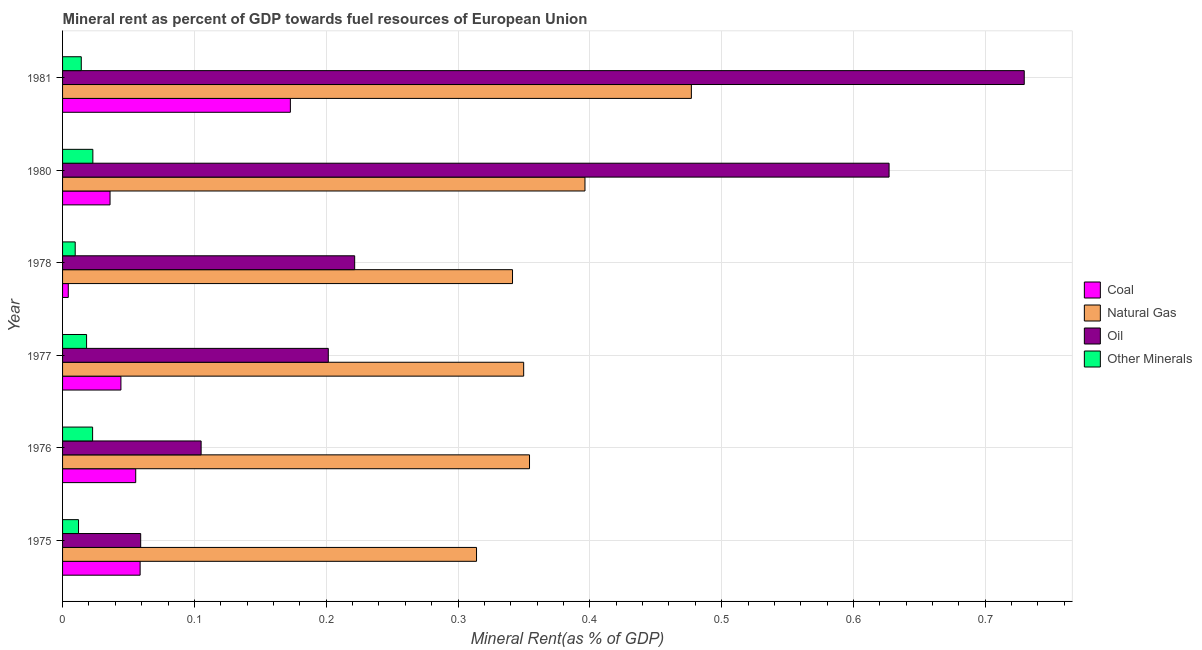How many different coloured bars are there?
Offer a terse response. 4. How many groups of bars are there?
Provide a short and direct response. 6. Are the number of bars per tick equal to the number of legend labels?
Your answer should be very brief. Yes. Are the number of bars on each tick of the Y-axis equal?
Provide a succinct answer. Yes. How many bars are there on the 1st tick from the top?
Ensure brevity in your answer.  4. What is the  rent of other minerals in 1978?
Give a very brief answer. 0.01. Across all years, what is the maximum coal rent?
Provide a short and direct response. 0.17. Across all years, what is the minimum natural gas rent?
Ensure brevity in your answer.  0.31. In which year was the coal rent minimum?
Your answer should be very brief. 1978. What is the total natural gas rent in the graph?
Offer a very short reply. 2.23. What is the difference between the natural gas rent in 1978 and that in 1980?
Ensure brevity in your answer.  -0.06. What is the difference between the  rent of other minerals in 1981 and the oil rent in 1975?
Keep it short and to the point. -0.05. What is the average natural gas rent per year?
Your answer should be compact. 0.37. In the year 1976, what is the difference between the oil rent and natural gas rent?
Your answer should be compact. -0.25. In how many years, is the oil rent greater than 0.4 %?
Your answer should be compact. 2. What is the ratio of the natural gas rent in 1976 to that in 1980?
Make the answer very short. 0.89. Is the  rent of other minerals in 1975 less than that in 1977?
Provide a short and direct response. Yes. What is the difference between the highest and the second highest oil rent?
Give a very brief answer. 0.1. What is the difference between the highest and the lowest natural gas rent?
Offer a terse response. 0.16. Is the sum of the  rent of other minerals in 1975 and 1976 greater than the maximum natural gas rent across all years?
Your response must be concise. No. What does the 2nd bar from the top in 1981 represents?
Keep it short and to the point. Oil. What does the 4th bar from the bottom in 1978 represents?
Make the answer very short. Other Minerals. Is it the case that in every year, the sum of the coal rent and natural gas rent is greater than the oil rent?
Offer a very short reply. No. How many years are there in the graph?
Offer a very short reply. 6. Are the values on the major ticks of X-axis written in scientific E-notation?
Make the answer very short. No. Does the graph contain grids?
Keep it short and to the point. Yes. What is the title of the graph?
Provide a short and direct response. Mineral rent as percent of GDP towards fuel resources of European Union. What is the label or title of the X-axis?
Your response must be concise. Mineral Rent(as % of GDP). What is the Mineral Rent(as % of GDP) in Coal in 1975?
Your response must be concise. 0.06. What is the Mineral Rent(as % of GDP) of Natural Gas in 1975?
Provide a succinct answer. 0.31. What is the Mineral Rent(as % of GDP) in Oil in 1975?
Your answer should be compact. 0.06. What is the Mineral Rent(as % of GDP) of Other Minerals in 1975?
Ensure brevity in your answer.  0.01. What is the Mineral Rent(as % of GDP) in Coal in 1976?
Your response must be concise. 0.06. What is the Mineral Rent(as % of GDP) in Natural Gas in 1976?
Your answer should be compact. 0.35. What is the Mineral Rent(as % of GDP) in Oil in 1976?
Provide a short and direct response. 0.11. What is the Mineral Rent(as % of GDP) in Other Minerals in 1976?
Keep it short and to the point. 0.02. What is the Mineral Rent(as % of GDP) of Coal in 1977?
Keep it short and to the point. 0.04. What is the Mineral Rent(as % of GDP) of Natural Gas in 1977?
Give a very brief answer. 0.35. What is the Mineral Rent(as % of GDP) in Oil in 1977?
Provide a succinct answer. 0.2. What is the Mineral Rent(as % of GDP) in Other Minerals in 1977?
Your response must be concise. 0.02. What is the Mineral Rent(as % of GDP) in Coal in 1978?
Make the answer very short. 0. What is the Mineral Rent(as % of GDP) of Natural Gas in 1978?
Give a very brief answer. 0.34. What is the Mineral Rent(as % of GDP) of Oil in 1978?
Offer a terse response. 0.22. What is the Mineral Rent(as % of GDP) of Other Minerals in 1978?
Give a very brief answer. 0.01. What is the Mineral Rent(as % of GDP) of Coal in 1980?
Your answer should be very brief. 0.04. What is the Mineral Rent(as % of GDP) of Natural Gas in 1980?
Make the answer very short. 0.4. What is the Mineral Rent(as % of GDP) in Oil in 1980?
Ensure brevity in your answer.  0.63. What is the Mineral Rent(as % of GDP) in Other Minerals in 1980?
Offer a terse response. 0.02. What is the Mineral Rent(as % of GDP) in Coal in 1981?
Ensure brevity in your answer.  0.17. What is the Mineral Rent(as % of GDP) of Natural Gas in 1981?
Your response must be concise. 0.48. What is the Mineral Rent(as % of GDP) in Oil in 1981?
Keep it short and to the point. 0.73. What is the Mineral Rent(as % of GDP) in Other Minerals in 1981?
Your answer should be very brief. 0.01. Across all years, what is the maximum Mineral Rent(as % of GDP) of Coal?
Your response must be concise. 0.17. Across all years, what is the maximum Mineral Rent(as % of GDP) of Natural Gas?
Provide a succinct answer. 0.48. Across all years, what is the maximum Mineral Rent(as % of GDP) of Oil?
Provide a short and direct response. 0.73. Across all years, what is the maximum Mineral Rent(as % of GDP) in Other Minerals?
Provide a succinct answer. 0.02. Across all years, what is the minimum Mineral Rent(as % of GDP) in Coal?
Give a very brief answer. 0. Across all years, what is the minimum Mineral Rent(as % of GDP) of Natural Gas?
Your response must be concise. 0.31. Across all years, what is the minimum Mineral Rent(as % of GDP) of Oil?
Your answer should be very brief. 0.06. Across all years, what is the minimum Mineral Rent(as % of GDP) in Other Minerals?
Make the answer very short. 0.01. What is the total Mineral Rent(as % of GDP) in Coal in the graph?
Your response must be concise. 0.37. What is the total Mineral Rent(as % of GDP) in Natural Gas in the graph?
Provide a succinct answer. 2.23. What is the total Mineral Rent(as % of GDP) in Oil in the graph?
Your answer should be compact. 1.94. What is the total Mineral Rent(as % of GDP) in Other Minerals in the graph?
Ensure brevity in your answer.  0.1. What is the difference between the Mineral Rent(as % of GDP) in Coal in 1975 and that in 1976?
Provide a succinct answer. 0. What is the difference between the Mineral Rent(as % of GDP) in Natural Gas in 1975 and that in 1976?
Provide a short and direct response. -0.04. What is the difference between the Mineral Rent(as % of GDP) of Oil in 1975 and that in 1976?
Ensure brevity in your answer.  -0.05. What is the difference between the Mineral Rent(as % of GDP) of Other Minerals in 1975 and that in 1976?
Give a very brief answer. -0.01. What is the difference between the Mineral Rent(as % of GDP) in Coal in 1975 and that in 1977?
Provide a short and direct response. 0.01. What is the difference between the Mineral Rent(as % of GDP) in Natural Gas in 1975 and that in 1977?
Offer a terse response. -0.04. What is the difference between the Mineral Rent(as % of GDP) of Oil in 1975 and that in 1977?
Offer a very short reply. -0.14. What is the difference between the Mineral Rent(as % of GDP) of Other Minerals in 1975 and that in 1977?
Give a very brief answer. -0.01. What is the difference between the Mineral Rent(as % of GDP) in Coal in 1975 and that in 1978?
Your answer should be very brief. 0.05. What is the difference between the Mineral Rent(as % of GDP) in Natural Gas in 1975 and that in 1978?
Give a very brief answer. -0.03. What is the difference between the Mineral Rent(as % of GDP) of Oil in 1975 and that in 1978?
Provide a succinct answer. -0.16. What is the difference between the Mineral Rent(as % of GDP) in Other Minerals in 1975 and that in 1978?
Provide a succinct answer. 0. What is the difference between the Mineral Rent(as % of GDP) of Coal in 1975 and that in 1980?
Provide a succinct answer. 0.02. What is the difference between the Mineral Rent(as % of GDP) in Natural Gas in 1975 and that in 1980?
Your response must be concise. -0.08. What is the difference between the Mineral Rent(as % of GDP) of Oil in 1975 and that in 1980?
Provide a short and direct response. -0.57. What is the difference between the Mineral Rent(as % of GDP) in Other Minerals in 1975 and that in 1980?
Provide a short and direct response. -0.01. What is the difference between the Mineral Rent(as % of GDP) in Coal in 1975 and that in 1981?
Provide a short and direct response. -0.11. What is the difference between the Mineral Rent(as % of GDP) in Natural Gas in 1975 and that in 1981?
Provide a short and direct response. -0.16. What is the difference between the Mineral Rent(as % of GDP) in Oil in 1975 and that in 1981?
Offer a terse response. -0.67. What is the difference between the Mineral Rent(as % of GDP) of Other Minerals in 1975 and that in 1981?
Your answer should be very brief. -0. What is the difference between the Mineral Rent(as % of GDP) of Coal in 1976 and that in 1977?
Keep it short and to the point. 0.01. What is the difference between the Mineral Rent(as % of GDP) in Natural Gas in 1976 and that in 1977?
Your response must be concise. 0. What is the difference between the Mineral Rent(as % of GDP) of Oil in 1976 and that in 1977?
Ensure brevity in your answer.  -0.1. What is the difference between the Mineral Rent(as % of GDP) in Other Minerals in 1976 and that in 1977?
Make the answer very short. 0. What is the difference between the Mineral Rent(as % of GDP) in Coal in 1976 and that in 1978?
Offer a terse response. 0.05. What is the difference between the Mineral Rent(as % of GDP) in Natural Gas in 1976 and that in 1978?
Keep it short and to the point. 0.01. What is the difference between the Mineral Rent(as % of GDP) of Oil in 1976 and that in 1978?
Your response must be concise. -0.12. What is the difference between the Mineral Rent(as % of GDP) of Other Minerals in 1976 and that in 1978?
Make the answer very short. 0.01. What is the difference between the Mineral Rent(as % of GDP) of Coal in 1976 and that in 1980?
Give a very brief answer. 0.02. What is the difference between the Mineral Rent(as % of GDP) in Natural Gas in 1976 and that in 1980?
Your response must be concise. -0.04. What is the difference between the Mineral Rent(as % of GDP) of Oil in 1976 and that in 1980?
Offer a terse response. -0.52. What is the difference between the Mineral Rent(as % of GDP) in Other Minerals in 1976 and that in 1980?
Your response must be concise. -0. What is the difference between the Mineral Rent(as % of GDP) in Coal in 1976 and that in 1981?
Your answer should be compact. -0.12. What is the difference between the Mineral Rent(as % of GDP) of Natural Gas in 1976 and that in 1981?
Keep it short and to the point. -0.12. What is the difference between the Mineral Rent(as % of GDP) in Oil in 1976 and that in 1981?
Your answer should be compact. -0.62. What is the difference between the Mineral Rent(as % of GDP) of Other Minerals in 1976 and that in 1981?
Provide a succinct answer. 0.01. What is the difference between the Mineral Rent(as % of GDP) in Coal in 1977 and that in 1978?
Provide a short and direct response. 0.04. What is the difference between the Mineral Rent(as % of GDP) in Natural Gas in 1977 and that in 1978?
Offer a terse response. 0.01. What is the difference between the Mineral Rent(as % of GDP) of Oil in 1977 and that in 1978?
Your answer should be very brief. -0.02. What is the difference between the Mineral Rent(as % of GDP) of Other Minerals in 1977 and that in 1978?
Give a very brief answer. 0.01. What is the difference between the Mineral Rent(as % of GDP) in Coal in 1977 and that in 1980?
Ensure brevity in your answer.  0.01. What is the difference between the Mineral Rent(as % of GDP) in Natural Gas in 1977 and that in 1980?
Give a very brief answer. -0.05. What is the difference between the Mineral Rent(as % of GDP) in Oil in 1977 and that in 1980?
Your answer should be very brief. -0.43. What is the difference between the Mineral Rent(as % of GDP) in Other Minerals in 1977 and that in 1980?
Give a very brief answer. -0. What is the difference between the Mineral Rent(as % of GDP) of Coal in 1977 and that in 1981?
Your answer should be compact. -0.13. What is the difference between the Mineral Rent(as % of GDP) in Natural Gas in 1977 and that in 1981?
Your answer should be compact. -0.13. What is the difference between the Mineral Rent(as % of GDP) in Oil in 1977 and that in 1981?
Offer a terse response. -0.53. What is the difference between the Mineral Rent(as % of GDP) of Other Minerals in 1977 and that in 1981?
Offer a terse response. 0. What is the difference between the Mineral Rent(as % of GDP) in Coal in 1978 and that in 1980?
Give a very brief answer. -0.03. What is the difference between the Mineral Rent(as % of GDP) of Natural Gas in 1978 and that in 1980?
Provide a short and direct response. -0.06. What is the difference between the Mineral Rent(as % of GDP) of Oil in 1978 and that in 1980?
Offer a terse response. -0.41. What is the difference between the Mineral Rent(as % of GDP) in Other Minerals in 1978 and that in 1980?
Offer a terse response. -0.01. What is the difference between the Mineral Rent(as % of GDP) in Coal in 1978 and that in 1981?
Give a very brief answer. -0.17. What is the difference between the Mineral Rent(as % of GDP) in Natural Gas in 1978 and that in 1981?
Your answer should be very brief. -0.14. What is the difference between the Mineral Rent(as % of GDP) of Oil in 1978 and that in 1981?
Offer a terse response. -0.51. What is the difference between the Mineral Rent(as % of GDP) in Other Minerals in 1978 and that in 1981?
Your answer should be very brief. -0. What is the difference between the Mineral Rent(as % of GDP) in Coal in 1980 and that in 1981?
Make the answer very short. -0.14. What is the difference between the Mineral Rent(as % of GDP) in Natural Gas in 1980 and that in 1981?
Offer a terse response. -0.08. What is the difference between the Mineral Rent(as % of GDP) in Oil in 1980 and that in 1981?
Provide a succinct answer. -0.1. What is the difference between the Mineral Rent(as % of GDP) of Other Minerals in 1980 and that in 1981?
Keep it short and to the point. 0.01. What is the difference between the Mineral Rent(as % of GDP) in Coal in 1975 and the Mineral Rent(as % of GDP) in Natural Gas in 1976?
Ensure brevity in your answer.  -0.3. What is the difference between the Mineral Rent(as % of GDP) in Coal in 1975 and the Mineral Rent(as % of GDP) in Oil in 1976?
Your answer should be very brief. -0.05. What is the difference between the Mineral Rent(as % of GDP) in Coal in 1975 and the Mineral Rent(as % of GDP) in Other Minerals in 1976?
Your answer should be compact. 0.04. What is the difference between the Mineral Rent(as % of GDP) in Natural Gas in 1975 and the Mineral Rent(as % of GDP) in Oil in 1976?
Keep it short and to the point. 0.21. What is the difference between the Mineral Rent(as % of GDP) in Natural Gas in 1975 and the Mineral Rent(as % of GDP) in Other Minerals in 1976?
Your response must be concise. 0.29. What is the difference between the Mineral Rent(as % of GDP) of Oil in 1975 and the Mineral Rent(as % of GDP) of Other Minerals in 1976?
Make the answer very short. 0.04. What is the difference between the Mineral Rent(as % of GDP) in Coal in 1975 and the Mineral Rent(as % of GDP) in Natural Gas in 1977?
Your answer should be very brief. -0.29. What is the difference between the Mineral Rent(as % of GDP) of Coal in 1975 and the Mineral Rent(as % of GDP) of Oil in 1977?
Offer a terse response. -0.14. What is the difference between the Mineral Rent(as % of GDP) of Coal in 1975 and the Mineral Rent(as % of GDP) of Other Minerals in 1977?
Make the answer very short. 0.04. What is the difference between the Mineral Rent(as % of GDP) in Natural Gas in 1975 and the Mineral Rent(as % of GDP) in Oil in 1977?
Your answer should be compact. 0.11. What is the difference between the Mineral Rent(as % of GDP) in Natural Gas in 1975 and the Mineral Rent(as % of GDP) in Other Minerals in 1977?
Ensure brevity in your answer.  0.3. What is the difference between the Mineral Rent(as % of GDP) in Oil in 1975 and the Mineral Rent(as % of GDP) in Other Minerals in 1977?
Make the answer very short. 0.04. What is the difference between the Mineral Rent(as % of GDP) of Coal in 1975 and the Mineral Rent(as % of GDP) of Natural Gas in 1978?
Your answer should be very brief. -0.28. What is the difference between the Mineral Rent(as % of GDP) in Coal in 1975 and the Mineral Rent(as % of GDP) in Oil in 1978?
Offer a very short reply. -0.16. What is the difference between the Mineral Rent(as % of GDP) of Coal in 1975 and the Mineral Rent(as % of GDP) of Other Minerals in 1978?
Offer a very short reply. 0.05. What is the difference between the Mineral Rent(as % of GDP) in Natural Gas in 1975 and the Mineral Rent(as % of GDP) in Oil in 1978?
Provide a succinct answer. 0.09. What is the difference between the Mineral Rent(as % of GDP) of Natural Gas in 1975 and the Mineral Rent(as % of GDP) of Other Minerals in 1978?
Make the answer very short. 0.3. What is the difference between the Mineral Rent(as % of GDP) of Oil in 1975 and the Mineral Rent(as % of GDP) of Other Minerals in 1978?
Your response must be concise. 0.05. What is the difference between the Mineral Rent(as % of GDP) in Coal in 1975 and the Mineral Rent(as % of GDP) in Natural Gas in 1980?
Provide a succinct answer. -0.34. What is the difference between the Mineral Rent(as % of GDP) of Coal in 1975 and the Mineral Rent(as % of GDP) of Oil in 1980?
Your answer should be compact. -0.57. What is the difference between the Mineral Rent(as % of GDP) of Coal in 1975 and the Mineral Rent(as % of GDP) of Other Minerals in 1980?
Make the answer very short. 0.04. What is the difference between the Mineral Rent(as % of GDP) of Natural Gas in 1975 and the Mineral Rent(as % of GDP) of Oil in 1980?
Provide a short and direct response. -0.31. What is the difference between the Mineral Rent(as % of GDP) in Natural Gas in 1975 and the Mineral Rent(as % of GDP) in Other Minerals in 1980?
Provide a short and direct response. 0.29. What is the difference between the Mineral Rent(as % of GDP) of Oil in 1975 and the Mineral Rent(as % of GDP) of Other Minerals in 1980?
Provide a succinct answer. 0.04. What is the difference between the Mineral Rent(as % of GDP) of Coal in 1975 and the Mineral Rent(as % of GDP) of Natural Gas in 1981?
Provide a succinct answer. -0.42. What is the difference between the Mineral Rent(as % of GDP) of Coal in 1975 and the Mineral Rent(as % of GDP) of Oil in 1981?
Give a very brief answer. -0.67. What is the difference between the Mineral Rent(as % of GDP) in Coal in 1975 and the Mineral Rent(as % of GDP) in Other Minerals in 1981?
Your answer should be very brief. 0.04. What is the difference between the Mineral Rent(as % of GDP) in Natural Gas in 1975 and the Mineral Rent(as % of GDP) in Oil in 1981?
Offer a very short reply. -0.42. What is the difference between the Mineral Rent(as % of GDP) in Natural Gas in 1975 and the Mineral Rent(as % of GDP) in Other Minerals in 1981?
Offer a terse response. 0.3. What is the difference between the Mineral Rent(as % of GDP) of Oil in 1975 and the Mineral Rent(as % of GDP) of Other Minerals in 1981?
Your answer should be very brief. 0.05. What is the difference between the Mineral Rent(as % of GDP) in Coal in 1976 and the Mineral Rent(as % of GDP) in Natural Gas in 1977?
Provide a short and direct response. -0.29. What is the difference between the Mineral Rent(as % of GDP) in Coal in 1976 and the Mineral Rent(as % of GDP) in Oil in 1977?
Give a very brief answer. -0.15. What is the difference between the Mineral Rent(as % of GDP) in Coal in 1976 and the Mineral Rent(as % of GDP) in Other Minerals in 1977?
Make the answer very short. 0.04. What is the difference between the Mineral Rent(as % of GDP) of Natural Gas in 1976 and the Mineral Rent(as % of GDP) of Oil in 1977?
Your answer should be very brief. 0.15. What is the difference between the Mineral Rent(as % of GDP) in Natural Gas in 1976 and the Mineral Rent(as % of GDP) in Other Minerals in 1977?
Give a very brief answer. 0.34. What is the difference between the Mineral Rent(as % of GDP) of Oil in 1976 and the Mineral Rent(as % of GDP) of Other Minerals in 1977?
Give a very brief answer. 0.09. What is the difference between the Mineral Rent(as % of GDP) in Coal in 1976 and the Mineral Rent(as % of GDP) in Natural Gas in 1978?
Offer a terse response. -0.29. What is the difference between the Mineral Rent(as % of GDP) in Coal in 1976 and the Mineral Rent(as % of GDP) in Oil in 1978?
Offer a very short reply. -0.17. What is the difference between the Mineral Rent(as % of GDP) in Coal in 1976 and the Mineral Rent(as % of GDP) in Other Minerals in 1978?
Your answer should be very brief. 0.05. What is the difference between the Mineral Rent(as % of GDP) of Natural Gas in 1976 and the Mineral Rent(as % of GDP) of Oil in 1978?
Provide a short and direct response. 0.13. What is the difference between the Mineral Rent(as % of GDP) in Natural Gas in 1976 and the Mineral Rent(as % of GDP) in Other Minerals in 1978?
Offer a terse response. 0.34. What is the difference between the Mineral Rent(as % of GDP) of Oil in 1976 and the Mineral Rent(as % of GDP) of Other Minerals in 1978?
Provide a short and direct response. 0.1. What is the difference between the Mineral Rent(as % of GDP) in Coal in 1976 and the Mineral Rent(as % of GDP) in Natural Gas in 1980?
Your answer should be very brief. -0.34. What is the difference between the Mineral Rent(as % of GDP) of Coal in 1976 and the Mineral Rent(as % of GDP) of Oil in 1980?
Give a very brief answer. -0.57. What is the difference between the Mineral Rent(as % of GDP) of Coal in 1976 and the Mineral Rent(as % of GDP) of Other Minerals in 1980?
Your answer should be very brief. 0.03. What is the difference between the Mineral Rent(as % of GDP) of Natural Gas in 1976 and the Mineral Rent(as % of GDP) of Oil in 1980?
Your answer should be compact. -0.27. What is the difference between the Mineral Rent(as % of GDP) of Natural Gas in 1976 and the Mineral Rent(as % of GDP) of Other Minerals in 1980?
Keep it short and to the point. 0.33. What is the difference between the Mineral Rent(as % of GDP) of Oil in 1976 and the Mineral Rent(as % of GDP) of Other Minerals in 1980?
Keep it short and to the point. 0.08. What is the difference between the Mineral Rent(as % of GDP) in Coal in 1976 and the Mineral Rent(as % of GDP) in Natural Gas in 1981?
Your response must be concise. -0.42. What is the difference between the Mineral Rent(as % of GDP) of Coal in 1976 and the Mineral Rent(as % of GDP) of Oil in 1981?
Your response must be concise. -0.67. What is the difference between the Mineral Rent(as % of GDP) of Coal in 1976 and the Mineral Rent(as % of GDP) of Other Minerals in 1981?
Offer a very short reply. 0.04. What is the difference between the Mineral Rent(as % of GDP) of Natural Gas in 1976 and the Mineral Rent(as % of GDP) of Oil in 1981?
Provide a succinct answer. -0.38. What is the difference between the Mineral Rent(as % of GDP) of Natural Gas in 1976 and the Mineral Rent(as % of GDP) of Other Minerals in 1981?
Offer a very short reply. 0.34. What is the difference between the Mineral Rent(as % of GDP) in Oil in 1976 and the Mineral Rent(as % of GDP) in Other Minerals in 1981?
Your response must be concise. 0.09. What is the difference between the Mineral Rent(as % of GDP) in Coal in 1977 and the Mineral Rent(as % of GDP) in Natural Gas in 1978?
Keep it short and to the point. -0.3. What is the difference between the Mineral Rent(as % of GDP) of Coal in 1977 and the Mineral Rent(as % of GDP) of Oil in 1978?
Your response must be concise. -0.18. What is the difference between the Mineral Rent(as % of GDP) in Coal in 1977 and the Mineral Rent(as % of GDP) in Other Minerals in 1978?
Provide a short and direct response. 0.03. What is the difference between the Mineral Rent(as % of GDP) in Natural Gas in 1977 and the Mineral Rent(as % of GDP) in Oil in 1978?
Give a very brief answer. 0.13. What is the difference between the Mineral Rent(as % of GDP) of Natural Gas in 1977 and the Mineral Rent(as % of GDP) of Other Minerals in 1978?
Your response must be concise. 0.34. What is the difference between the Mineral Rent(as % of GDP) of Oil in 1977 and the Mineral Rent(as % of GDP) of Other Minerals in 1978?
Provide a short and direct response. 0.19. What is the difference between the Mineral Rent(as % of GDP) of Coal in 1977 and the Mineral Rent(as % of GDP) of Natural Gas in 1980?
Keep it short and to the point. -0.35. What is the difference between the Mineral Rent(as % of GDP) in Coal in 1977 and the Mineral Rent(as % of GDP) in Oil in 1980?
Your answer should be compact. -0.58. What is the difference between the Mineral Rent(as % of GDP) of Coal in 1977 and the Mineral Rent(as % of GDP) of Other Minerals in 1980?
Give a very brief answer. 0.02. What is the difference between the Mineral Rent(as % of GDP) in Natural Gas in 1977 and the Mineral Rent(as % of GDP) in Oil in 1980?
Give a very brief answer. -0.28. What is the difference between the Mineral Rent(as % of GDP) in Natural Gas in 1977 and the Mineral Rent(as % of GDP) in Other Minerals in 1980?
Your response must be concise. 0.33. What is the difference between the Mineral Rent(as % of GDP) of Oil in 1977 and the Mineral Rent(as % of GDP) of Other Minerals in 1980?
Ensure brevity in your answer.  0.18. What is the difference between the Mineral Rent(as % of GDP) of Coal in 1977 and the Mineral Rent(as % of GDP) of Natural Gas in 1981?
Your answer should be very brief. -0.43. What is the difference between the Mineral Rent(as % of GDP) in Coal in 1977 and the Mineral Rent(as % of GDP) in Oil in 1981?
Ensure brevity in your answer.  -0.69. What is the difference between the Mineral Rent(as % of GDP) in Coal in 1977 and the Mineral Rent(as % of GDP) in Other Minerals in 1981?
Your response must be concise. 0.03. What is the difference between the Mineral Rent(as % of GDP) in Natural Gas in 1977 and the Mineral Rent(as % of GDP) in Oil in 1981?
Ensure brevity in your answer.  -0.38. What is the difference between the Mineral Rent(as % of GDP) of Natural Gas in 1977 and the Mineral Rent(as % of GDP) of Other Minerals in 1981?
Give a very brief answer. 0.34. What is the difference between the Mineral Rent(as % of GDP) of Oil in 1977 and the Mineral Rent(as % of GDP) of Other Minerals in 1981?
Make the answer very short. 0.19. What is the difference between the Mineral Rent(as % of GDP) in Coal in 1978 and the Mineral Rent(as % of GDP) in Natural Gas in 1980?
Offer a terse response. -0.39. What is the difference between the Mineral Rent(as % of GDP) in Coal in 1978 and the Mineral Rent(as % of GDP) in Oil in 1980?
Offer a terse response. -0.62. What is the difference between the Mineral Rent(as % of GDP) of Coal in 1978 and the Mineral Rent(as % of GDP) of Other Minerals in 1980?
Offer a very short reply. -0.02. What is the difference between the Mineral Rent(as % of GDP) in Natural Gas in 1978 and the Mineral Rent(as % of GDP) in Oil in 1980?
Ensure brevity in your answer.  -0.29. What is the difference between the Mineral Rent(as % of GDP) of Natural Gas in 1978 and the Mineral Rent(as % of GDP) of Other Minerals in 1980?
Your response must be concise. 0.32. What is the difference between the Mineral Rent(as % of GDP) of Oil in 1978 and the Mineral Rent(as % of GDP) of Other Minerals in 1980?
Your answer should be very brief. 0.2. What is the difference between the Mineral Rent(as % of GDP) of Coal in 1978 and the Mineral Rent(as % of GDP) of Natural Gas in 1981?
Your answer should be very brief. -0.47. What is the difference between the Mineral Rent(as % of GDP) in Coal in 1978 and the Mineral Rent(as % of GDP) in Oil in 1981?
Provide a short and direct response. -0.73. What is the difference between the Mineral Rent(as % of GDP) of Coal in 1978 and the Mineral Rent(as % of GDP) of Other Minerals in 1981?
Provide a succinct answer. -0.01. What is the difference between the Mineral Rent(as % of GDP) of Natural Gas in 1978 and the Mineral Rent(as % of GDP) of Oil in 1981?
Offer a very short reply. -0.39. What is the difference between the Mineral Rent(as % of GDP) in Natural Gas in 1978 and the Mineral Rent(as % of GDP) in Other Minerals in 1981?
Provide a short and direct response. 0.33. What is the difference between the Mineral Rent(as % of GDP) in Oil in 1978 and the Mineral Rent(as % of GDP) in Other Minerals in 1981?
Provide a short and direct response. 0.21. What is the difference between the Mineral Rent(as % of GDP) of Coal in 1980 and the Mineral Rent(as % of GDP) of Natural Gas in 1981?
Offer a very short reply. -0.44. What is the difference between the Mineral Rent(as % of GDP) in Coal in 1980 and the Mineral Rent(as % of GDP) in Oil in 1981?
Give a very brief answer. -0.69. What is the difference between the Mineral Rent(as % of GDP) in Coal in 1980 and the Mineral Rent(as % of GDP) in Other Minerals in 1981?
Ensure brevity in your answer.  0.02. What is the difference between the Mineral Rent(as % of GDP) of Natural Gas in 1980 and the Mineral Rent(as % of GDP) of Oil in 1981?
Your response must be concise. -0.33. What is the difference between the Mineral Rent(as % of GDP) of Natural Gas in 1980 and the Mineral Rent(as % of GDP) of Other Minerals in 1981?
Provide a succinct answer. 0.38. What is the difference between the Mineral Rent(as % of GDP) of Oil in 1980 and the Mineral Rent(as % of GDP) of Other Minerals in 1981?
Ensure brevity in your answer.  0.61. What is the average Mineral Rent(as % of GDP) of Coal per year?
Offer a very short reply. 0.06. What is the average Mineral Rent(as % of GDP) of Natural Gas per year?
Keep it short and to the point. 0.37. What is the average Mineral Rent(as % of GDP) in Oil per year?
Offer a very short reply. 0.32. What is the average Mineral Rent(as % of GDP) in Other Minerals per year?
Give a very brief answer. 0.02. In the year 1975, what is the difference between the Mineral Rent(as % of GDP) in Coal and Mineral Rent(as % of GDP) in Natural Gas?
Offer a terse response. -0.26. In the year 1975, what is the difference between the Mineral Rent(as % of GDP) of Coal and Mineral Rent(as % of GDP) of Oil?
Make the answer very short. -0. In the year 1975, what is the difference between the Mineral Rent(as % of GDP) of Coal and Mineral Rent(as % of GDP) of Other Minerals?
Offer a very short reply. 0.05. In the year 1975, what is the difference between the Mineral Rent(as % of GDP) of Natural Gas and Mineral Rent(as % of GDP) of Oil?
Your answer should be compact. 0.25. In the year 1975, what is the difference between the Mineral Rent(as % of GDP) of Natural Gas and Mineral Rent(as % of GDP) of Other Minerals?
Offer a terse response. 0.3. In the year 1975, what is the difference between the Mineral Rent(as % of GDP) in Oil and Mineral Rent(as % of GDP) in Other Minerals?
Give a very brief answer. 0.05. In the year 1976, what is the difference between the Mineral Rent(as % of GDP) in Coal and Mineral Rent(as % of GDP) in Natural Gas?
Your answer should be compact. -0.3. In the year 1976, what is the difference between the Mineral Rent(as % of GDP) of Coal and Mineral Rent(as % of GDP) of Oil?
Your answer should be compact. -0.05. In the year 1976, what is the difference between the Mineral Rent(as % of GDP) in Coal and Mineral Rent(as % of GDP) in Other Minerals?
Your response must be concise. 0.03. In the year 1976, what is the difference between the Mineral Rent(as % of GDP) in Natural Gas and Mineral Rent(as % of GDP) in Oil?
Your answer should be very brief. 0.25. In the year 1976, what is the difference between the Mineral Rent(as % of GDP) in Natural Gas and Mineral Rent(as % of GDP) in Other Minerals?
Offer a very short reply. 0.33. In the year 1976, what is the difference between the Mineral Rent(as % of GDP) of Oil and Mineral Rent(as % of GDP) of Other Minerals?
Ensure brevity in your answer.  0.08. In the year 1977, what is the difference between the Mineral Rent(as % of GDP) of Coal and Mineral Rent(as % of GDP) of Natural Gas?
Offer a very short reply. -0.31. In the year 1977, what is the difference between the Mineral Rent(as % of GDP) of Coal and Mineral Rent(as % of GDP) of Oil?
Your answer should be compact. -0.16. In the year 1977, what is the difference between the Mineral Rent(as % of GDP) of Coal and Mineral Rent(as % of GDP) of Other Minerals?
Offer a very short reply. 0.03. In the year 1977, what is the difference between the Mineral Rent(as % of GDP) of Natural Gas and Mineral Rent(as % of GDP) of Oil?
Offer a terse response. 0.15. In the year 1977, what is the difference between the Mineral Rent(as % of GDP) of Natural Gas and Mineral Rent(as % of GDP) of Other Minerals?
Keep it short and to the point. 0.33. In the year 1977, what is the difference between the Mineral Rent(as % of GDP) in Oil and Mineral Rent(as % of GDP) in Other Minerals?
Ensure brevity in your answer.  0.18. In the year 1978, what is the difference between the Mineral Rent(as % of GDP) in Coal and Mineral Rent(as % of GDP) in Natural Gas?
Ensure brevity in your answer.  -0.34. In the year 1978, what is the difference between the Mineral Rent(as % of GDP) of Coal and Mineral Rent(as % of GDP) of Oil?
Make the answer very short. -0.22. In the year 1978, what is the difference between the Mineral Rent(as % of GDP) of Coal and Mineral Rent(as % of GDP) of Other Minerals?
Offer a very short reply. -0.01. In the year 1978, what is the difference between the Mineral Rent(as % of GDP) of Natural Gas and Mineral Rent(as % of GDP) of Oil?
Your answer should be compact. 0.12. In the year 1978, what is the difference between the Mineral Rent(as % of GDP) in Natural Gas and Mineral Rent(as % of GDP) in Other Minerals?
Make the answer very short. 0.33. In the year 1978, what is the difference between the Mineral Rent(as % of GDP) in Oil and Mineral Rent(as % of GDP) in Other Minerals?
Make the answer very short. 0.21. In the year 1980, what is the difference between the Mineral Rent(as % of GDP) in Coal and Mineral Rent(as % of GDP) in Natural Gas?
Provide a short and direct response. -0.36. In the year 1980, what is the difference between the Mineral Rent(as % of GDP) in Coal and Mineral Rent(as % of GDP) in Oil?
Your answer should be very brief. -0.59. In the year 1980, what is the difference between the Mineral Rent(as % of GDP) in Coal and Mineral Rent(as % of GDP) in Other Minerals?
Ensure brevity in your answer.  0.01. In the year 1980, what is the difference between the Mineral Rent(as % of GDP) of Natural Gas and Mineral Rent(as % of GDP) of Oil?
Provide a short and direct response. -0.23. In the year 1980, what is the difference between the Mineral Rent(as % of GDP) of Natural Gas and Mineral Rent(as % of GDP) of Other Minerals?
Make the answer very short. 0.37. In the year 1980, what is the difference between the Mineral Rent(as % of GDP) of Oil and Mineral Rent(as % of GDP) of Other Minerals?
Your answer should be compact. 0.6. In the year 1981, what is the difference between the Mineral Rent(as % of GDP) of Coal and Mineral Rent(as % of GDP) of Natural Gas?
Your response must be concise. -0.3. In the year 1981, what is the difference between the Mineral Rent(as % of GDP) in Coal and Mineral Rent(as % of GDP) in Oil?
Ensure brevity in your answer.  -0.56. In the year 1981, what is the difference between the Mineral Rent(as % of GDP) in Coal and Mineral Rent(as % of GDP) in Other Minerals?
Your answer should be very brief. 0.16. In the year 1981, what is the difference between the Mineral Rent(as % of GDP) of Natural Gas and Mineral Rent(as % of GDP) of Oil?
Offer a terse response. -0.25. In the year 1981, what is the difference between the Mineral Rent(as % of GDP) in Natural Gas and Mineral Rent(as % of GDP) in Other Minerals?
Your answer should be compact. 0.46. In the year 1981, what is the difference between the Mineral Rent(as % of GDP) of Oil and Mineral Rent(as % of GDP) of Other Minerals?
Give a very brief answer. 0.72. What is the ratio of the Mineral Rent(as % of GDP) in Coal in 1975 to that in 1976?
Offer a terse response. 1.06. What is the ratio of the Mineral Rent(as % of GDP) of Natural Gas in 1975 to that in 1976?
Your answer should be compact. 0.89. What is the ratio of the Mineral Rent(as % of GDP) in Oil in 1975 to that in 1976?
Give a very brief answer. 0.56. What is the ratio of the Mineral Rent(as % of GDP) of Other Minerals in 1975 to that in 1976?
Keep it short and to the point. 0.53. What is the ratio of the Mineral Rent(as % of GDP) of Coal in 1975 to that in 1977?
Your response must be concise. 1.33. What is the ratio of the Mineral Rent(as % of GDP) in Natural Gas in 1975 to that in 1977?
Give a very brief answer. 0.9. What is the ratio of the Mineral Rent(as % of GDP) of Oil in 1975 to that in 1977?
Your answer should be very brief. 0.29. What is the ratio of the Mineral Rent(as % of GDP) in Other Minerals in 1975 to that in 1977?
Offer a terse response. 0.66. What is the ratio of the Mineral Rent(as % of GDP) of Coal in 1975 to that in 1978?
Provide a short and direct response. 13.59. What is the ratio of the Mineral Rent(as % of GDP) of Natural Gas in 1975 to that in 1978?
Offer a very short reply. 0.92. What is the ratio of the Mineral Rent(as % of GDP) of Oil in 1975 to that in 1978?
Provide a succinct answer. 0.27. What is the ratio of the Mineral Rent(as % of GDP) in Other Minerals in 1975 to that in 1978?
Keep it short and to the point. 1.26. What is the ratio of the Mineral Rent(as % of GDP) in Coal in 1975 to that in 1980?
Provide a succinct answer. 1.63. What is the ratio of the Mineral Rent(as % of GDP) in Natural Gas in 1975 to that in 1980?
Provide a short and direct response. 0.79. What is the ratio of the Mineral Rent(as % of GDP) in Oil in 1975 to that in 1980?
Your answer should be compact. 0.09. What is the ratio of the Mineral Rent(as % of GDP) of Other Minerals in 1975 to that in 1980?
Your answer should be very brief. 0.53. What is the ratio of the Mineral Rent(as % of GDP) in Coal in 1975 to that in 1981?
Your response must be concise. 0.34. What is the ratio of the Mineral Rent(as % of GDP) of Natural Gas in 1975 to that in 1981?
Ensure brevity in your answer.  0.66. What is the ratio of the Mineral Rent(as % of GDP) of Oil in 1975 to that in 1981?
Make the answer very short. 0.08. What is the ratio of the Mineral Rent(as % of GDP) in Other Minerals in 1975 to that in 1981?
Offer a very short reply. 0.85. What is the ratio of the Mineral Rent(as % of GDP) in Coal in 1976 to that in 1977?
Make the answer very short. 1.25. What is the ratio of the Mineral Rent(as % of GDP) in Natural Gas in 1976 to that in 1977?
Ensure brevity in your answer.  1.01. What is the ratio of the Mineral Rent(as % of GDP) in Oil in 1976 to that in 1977?
Offer a very short reply. 0.52. What is the ratio of the Mineral Rent(as % of GDP) of Other Minerals in 1976 to that in 1977?
Your response must be concise. 1.25. What is the ratio of the Mineral Rent(as % of GDP) in Coal in 1976 to that in 1978?
Offer a very short reply. 12.81. What is the ratio of the Mineral Rent(as % of GDP) of Natural Gas in 1976 to that in 1978?
Make the answer very short. 1.04. What is the ratio of the Mineral Rent(as % of GDP) of Oil in 1976 to that in 1978?
Your answer should be compact. 0.47. What is the ratio of the Mineral Rent(as % of GDP) of Other Minerals in 1976 to that in 1978?
Your answer should be very brief. 2.38. What is the ratio of the Mineral Rent(as % of GDP) in Coal in 1976 to that in 1980?
Offer a terse response. 1.54. What is the ratio of the Mineral Rent(as % of GDP) of Natural Gas in 1976 to that in 1980?
Provide a succinct answer. 0.89. What is the ratio of the Mineral Rent(as % of GDP) in Oil in 1976 to that in 1980?
Your answer should be compact. 0.17. What is the ratio of the Mineral Rent(as % of GDP) of Other Minerals in 1976 to that in 1980?
Keep it short and to the point. 0.99. What is the ratio of the Mineral Rent(as % of GDP) of Coal in 1976 to that in 1981?
Ensure brevity in your answer.  0.32. What is the ratio of the Mineral Rent(as % of GDP) of Natural Gas in 1976 to that in 1981?
Ensure brevity in your answer.  0.74. What is the ratio of the Mineral Rent(as % of GDP) in Oil in 1976 to that in 1981?
Keep it short and to the point. 0.14. What is the ratio of the Mineral Rent(as % of GDP) in Other Minerals in 1976 to that in 1981?
Ensure brevity in your answer.  1.6. What is the ratio of the Mineral Rent(as % of GDP) of Coal in 1977 to that in 1978?
Make the answer very short. 10.22. What is the ratio of the Mineral Rent(as % of GDP) in Natural Gas in 1977 to that in 1978?
Your response must be concise. 1.02. What is the ratio of the Mineral Rent(as % of GDP) of Oil in 1977 to that in 1978?
Provide a short and direct response. 0.91. What is the ratio of the Mineral Rent(as % of GDP) in Other Minerals in 1977 to that in 1978?
Your response must be concise. 1.9. What is the ratio of the Mineral Rent(as % of GDP) of Coal in 1977 to that in 1980?
Keep it short and to the point. 1.23. What is the ratio of the Mineral Rent(as % of GDP) of Natural Gas in 1977 to that in 1980?
Make the answer very short. 0.88. What is the ratio of the Mineral Rent(as % of GDP) of Oil in 1977 to that in 1980?
Your answer should be compact. 0.32. What is the ratio of the Mineral Rent(as % of GDP) of Other Minerals in 1977 to that in 1980?
Ensure brevity in your answer.  0.79. What is the ratio of the Mineral Rent(as % of GDP) of Coal in 1977 to that in 1981?
Provide a short and direct response. 0.26. What is the ratio of the Mineral Rent(as % of GDP) of Natural Gas in 1977 to that in 1981?
Make the answer very short. 0.73. What is the ratio of the Mineral Rent(as % of GDP) in Oil in 1977 to that in 1981?
Make the answer very short. 0.28. What is the ratio of the Mineral Rent(as % of GDP) in Other Minerals in 1977 to that in 1981?
Provide a short and direct response. 1.28. What is the ratio of the Mineral Rent(as % of GDP) in Coal in 1978 to that in 1980?
Keep it short and to the point. 0.12. What is the ratio of the Mineral Rent(as % of GDP) in Natural Gas in 1978 to that in 1980?
Offer a terse response. 0.86. What is the ratio of the Mineral Rent(as % of GDP) of Oil in 1978 to that in 1980?
Your response must be concise. 0.35. What is the ratio of the Mineral Rent(as % of GDP) in Other Minerals in 1978 to that in 1980?
Provide a succinct answer. 0.42. What is the ratio of the Mineral Rent(as % of GDP) in Coal in 1978 to that in 1981?
Offer a terse response. 0.03. What is the ratio of the Mineral Rent(as % of GDP) of Natural Gas in 1978 to that in 1981?
Provide a succinct answer. 0.72. What is the ratio of the Mineral Rent(as % of GDP) of Oil in 1978 to that in 1981?
Your response must be concise. 0.3. What is the ratio of the Mineral Rent(as % of GDP) of Other Minerals in 1978 to that in 1981?
Give a very brief answer. 0.68. What is the ratio of the Mineral Rent(as % of GDP) in Coal in 1980 to that in 1981?
Keep it short and to the point. 0.21. What is the ratio of the Mineral Rent(as % of GDP) in Natural Gas in 1980 to that in 1981?
Your answer should be compact. 0.83. What is the ratio of the Mineral Rent(as % of GDP) of Oil in 1980 to that in 1981?
Your answer should be compact. 0.86. What is the ratio of the Mineral Rent(as % of GDP) of Other Minerals in 1980 to that in 1981?
Your answer should be very brief. 1.62. What is the difference between the highest and the second highest Mineral Rent(as % of GDP) in Coal?
Offer a very short reply. 0.11. What is the difference between the highest and the second highest Mineral Rent(as % of GDP) in Natural Gas?
Keep it short and to the point. 0.08. What is the difference between the highest and the second highest Mineral Rent(as % of GDP) of Oil?
Your answer should be very brief. 0.1. What is the difference between the highest and the lowest Mineral Rent(as % of GDP) in Coal?
Ensure brevity in your answer.  0.17. What is the difference between the highest and the lowest Mineral Rent(as % of GDP) in Natural Gas?
Provide a succinct answer. 0.16. What is the difference between the highest and the lowest Mineral Rent(as % of GDP) in Oil?
Keep it short and to the point. 0.67. What is the difference between the highest and the lowest Mineral Rent(as % of GDP) of Other Minerals?
Ensure brevity in your answer.  0.01. 